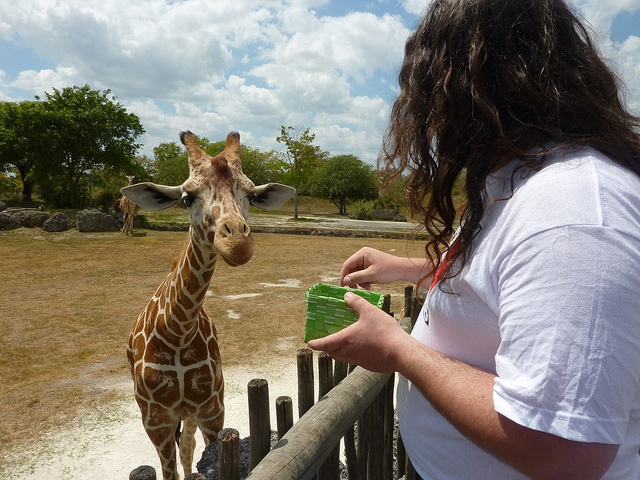Describe the objects in this image and their specific colors. I can see people in lightgray, black, lavender, darkgray, and maroon tones, giraffe in lightgray, black, olive, maroon, and gray tones, and giraffe in lightgray, olive, black, maroon, and gray tones in this image. 